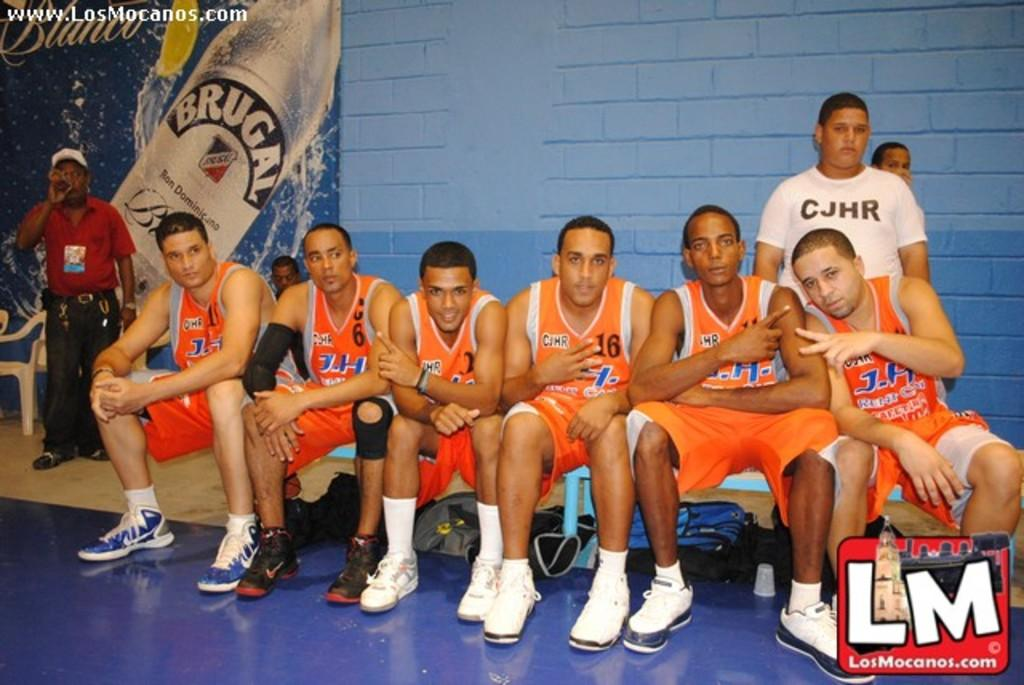<image>
Present a compact description of the photo's key features. The J.H. team sits together on a bench. 